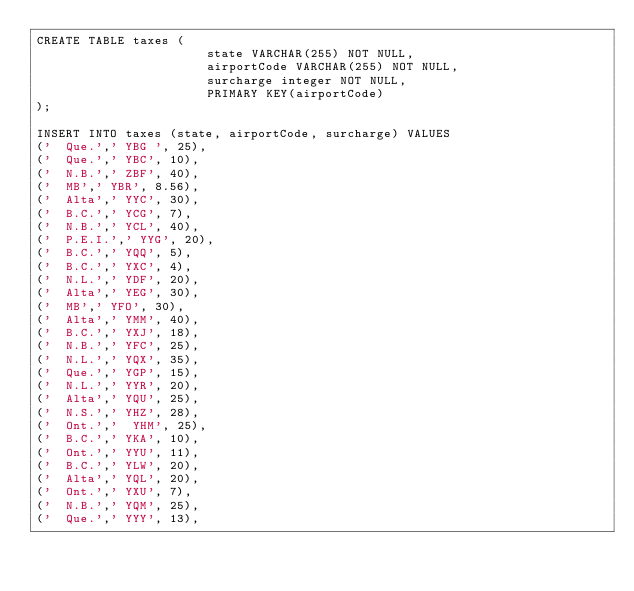Convert code to text. <code><loc_0><loc_0><loc_500><loc_500><_SQL_>CREATE TABLE taxes (
                       state VARCHAR(255) NOT NULL,
                       airportCode VARCHAR(255) NOT NULL,
                       surcharge integer NOT NULL,
                       PRIMARY KEY(airportCode)
);

INSERT INTO taxes (state, airportCode, surcharge) VALUES
('  Que.',' YBG ', 25),
('  Que.',' YBC', 10),
('  N.B.',' ZBF', 40),
('  MB',' YBR', 8.56),
('  Alta',' YYC', 30),
('  B.C.',' YCG', 7),
('  N.B.',' YCL', 40),
('  P.E.I.',' YYG', 20),
('  B.C.',' YQQ', 5),
('  B.C.',' YXC', 4),
('  N.L.',' YDF', 20),
('  Alta',' YEG', 30),
('  MB',' YFO', 30),
('  Alta',' YMM', 40),
('  B.C.',' YXJ', 18),
('  N.B.',' YFC', 25),
('  N.L.',' YQX', 35),
('  Que.',' YGP', 15),
('  N.L.',' YYR', 20),
('  Alta',' YQU', 25),
('  N.S.',' YHZ', 28),
('  Ont.','  YHM', 25),
('  B.C.',' YKA', 10),
('  Ont.',' YYU', 11),
('  B.C.',' YLW', 20),
('  Alta',' YQL', 20),
('  Ont.',' YXU', 7),
('  N.B.',' YQM', 25),
('  Que.',' YYY', 13),</code> 